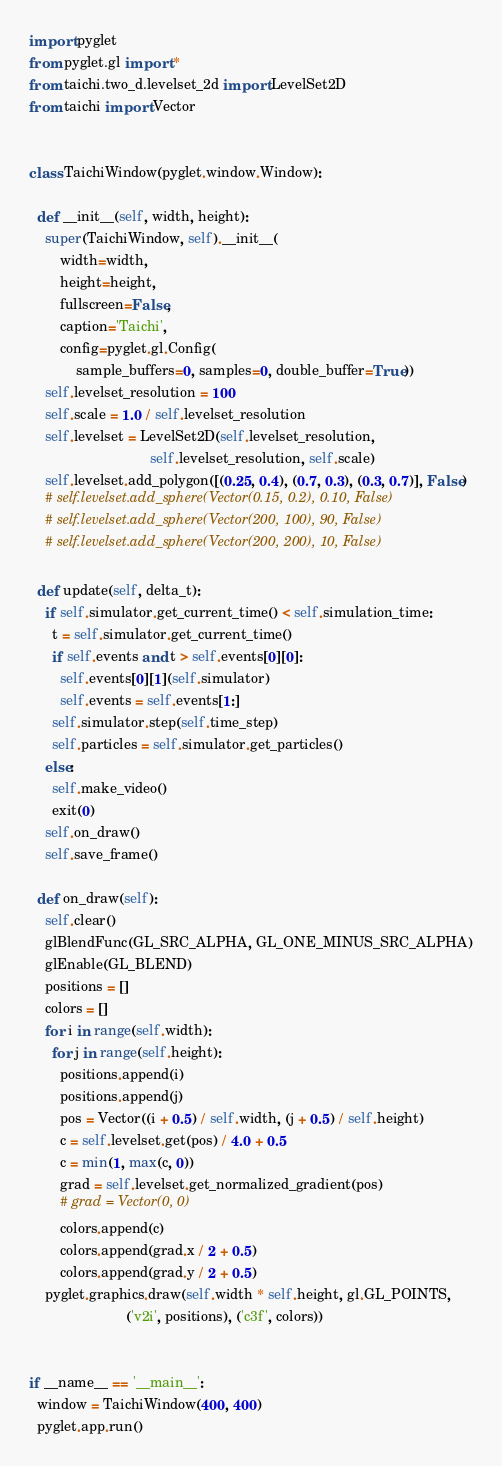Convert code to text. <code><loc_0><loc_0><loc_500><loc_500><_Python_>import pyglet
from pyglet.gl import *
from taichi.two_d.levelset_2d import LevelSet2D
from taichi import Vector


class TaichiWindow(pyglet.window.Window):

  def __init__(self, width, height):
    super(TaichiWindow, self).__init__(
        width=width,
        height=height,
        fullscreen=False,
        caption='Taichi',
        config=pyglet.gl.Config(
            sample_buffers=0, samples=0, double_buffer=True))
    self.levelset_resolution = 100
    self.scale = 1.0 / self.levelset_resolution
    self.levelset = LevelSet2D(self.levelset_resolution,
                               self.levelset_resolution, self.scale)
    self.levelset.add_polygon([(0.25, 0.4), (0.7, 0.3), (0.3, 0.7)], False)
    # self.levelset.add_sphere(Vector(0.15, 0.2), 0.10, False)
    # self.levelset.add_sphere(Vector(200, 100), 90, False)
    # self.levelset.add_sphere(Vector(200, 200), 10, False)

  def update(self, delta_t):
    if self.simulator.get_current_time() < self.simulation_time:
      t = self.simulator.get_current_time()
      if self.events and t > self.events[0][0]:
        self.events[0][1](self.simulator)
        self.events = self.events[1:]
      self.simulator.step(self.time_step)
      self.particles = self.simulator.get_particles()
    else:
      self.make_video()
      exit(0)
    self.on_draw()
    self.save_frame()

  def on_draw(self):
    self.clear()
    glBlendFunc(GL_SRC_ALPHA, GL_ONE_MINUS_SRC_ALPHA)
    glEnable(GL_BLEND)
    positions = []
    colors = []
    for i in range(self.width):
      for j in range(self.height):
        positions.append(i)
        positions.append(j)
        pos = Vector((i + 0.5) / self.width, (j + 0.5) / self.height)
        c = self.levelset.get(pos) / 4.0 + 0.5
        c = min(1, max(c, 0))
        grad = self.levelset.get_normalized_gradient(pos)
        # grad = Vector(0, 0)
        colors.append(c)
        colors.append(grad.x / 2 + 0.5)
        colors.append(grad.y / 2 + 0.5)
    pyglet.graphics.draw(self.width * self.height, gl.GL_POINTS,
                         ('v2i', positions), ('c3f', colors))


if __name__ == '__main__':
  window = TaichiWindow(400, 400)
  pyglet.app.run()
</code> 